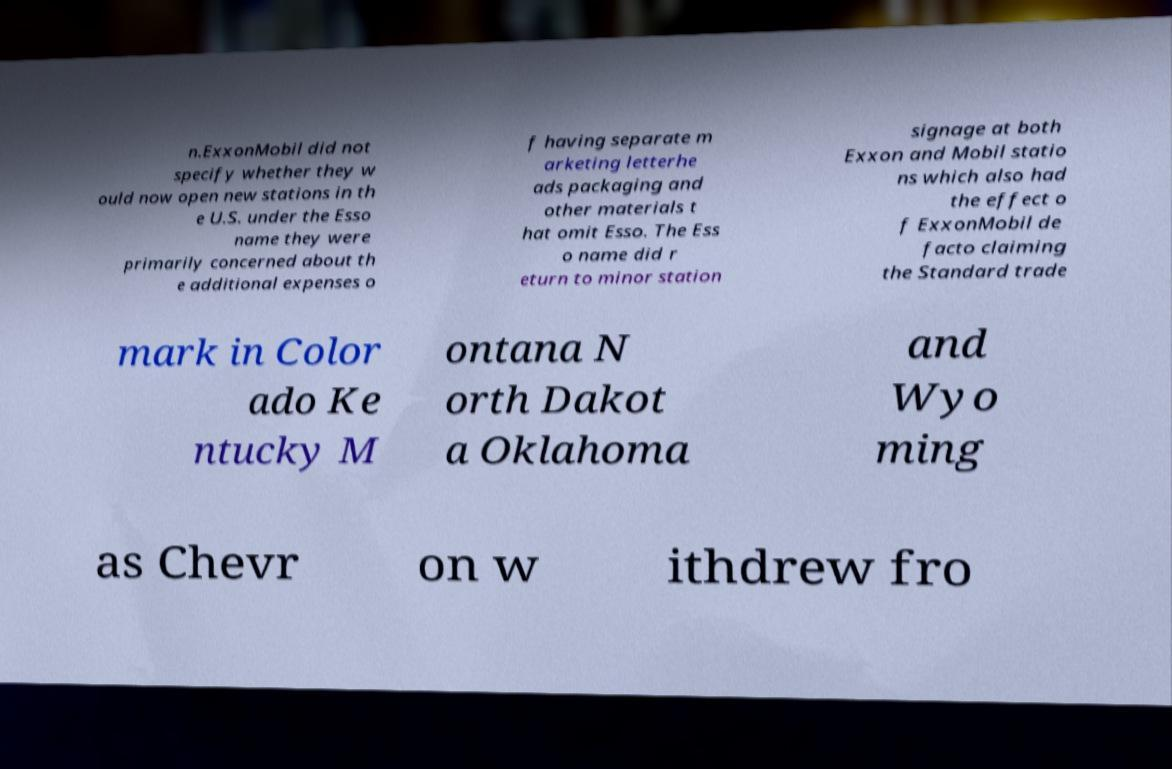Can you read and provide the text displayed in the image?This photo seems to have some interesting text. Can you extract and type it out for me? n.ExxonMobil did not specify whether they w ould now open new stations in th e U.S. under the Esso name they were primarily concerned about th e additional expenses o f having separate m arketing letterhe ads packaging and other materials t hat omit Esso. The Ess o name did r eturn to minor station signage at both Exxon and Mobil statio ns which also had the effect o f ExxonMobil de facto claiming the Standard trade mark in Color ado Ke ntucky M ontana N orth Dakot a Oklahoma and Wyo ming as Chevr on w ithdrew fro 